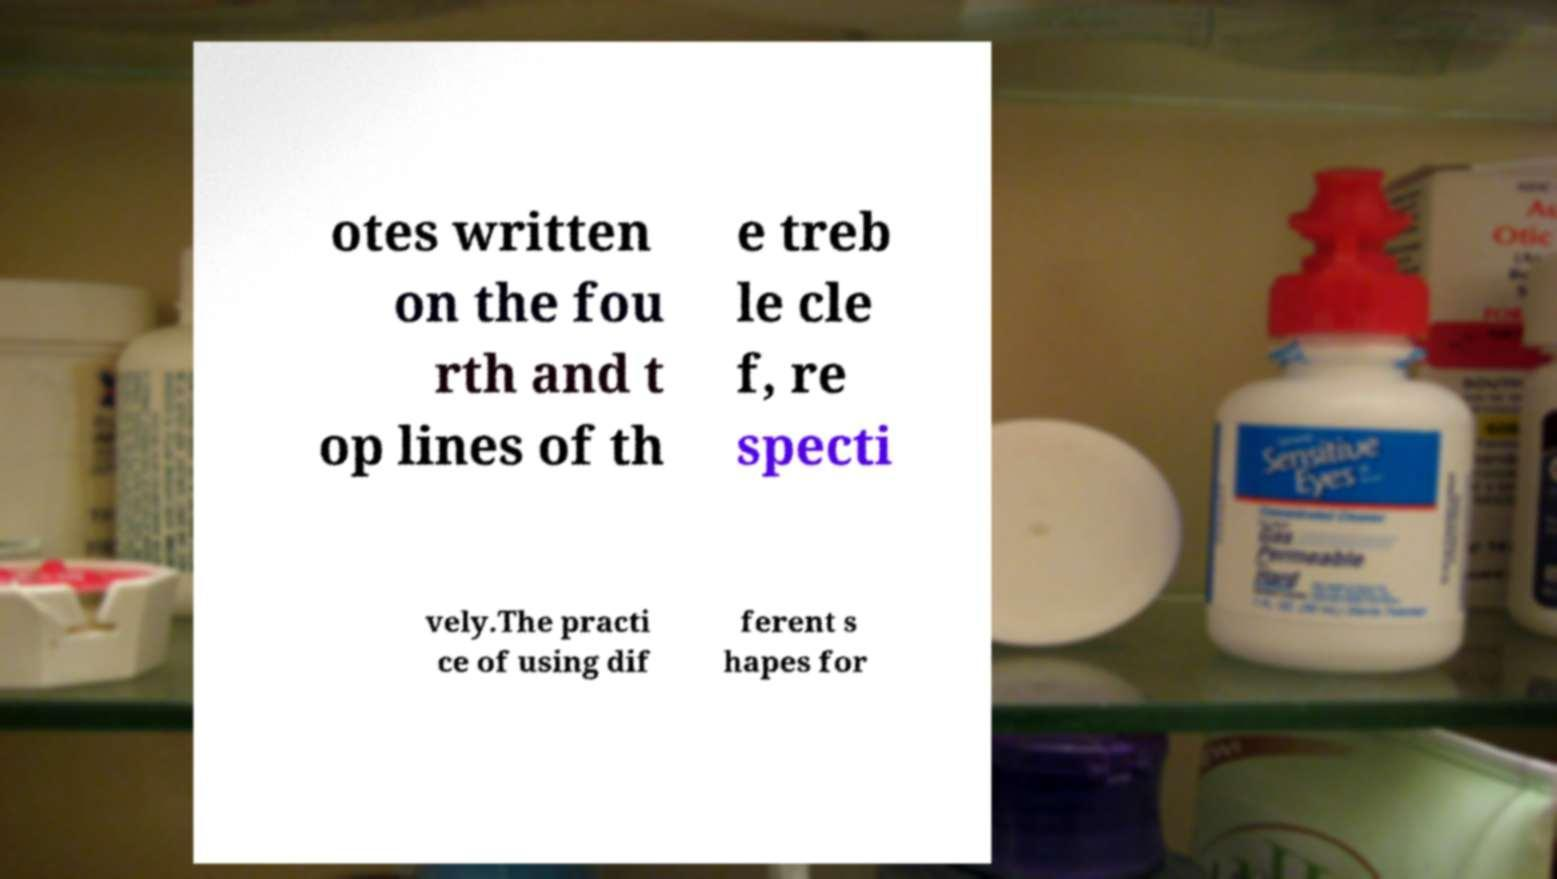Please read and relay the text visible in this image. What does it say? otes written on the fou rth and t op lines of th e treb le cle f, re specti vely.The practi ce of using dif ferent s hapes for 